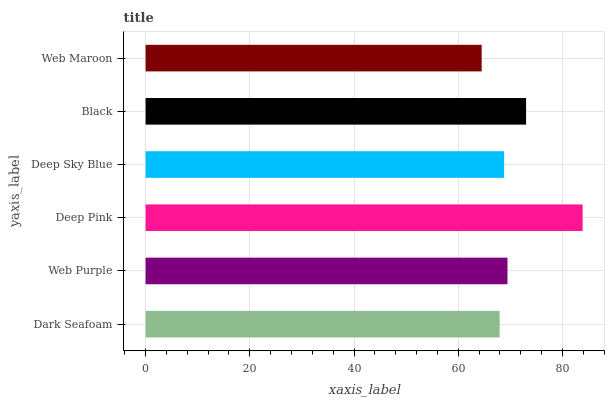Is Web Maroon the minimum?
Answer yes or no. Yes. Is Deep Pink the maximum?
Answer yes or no. Yes. Is Web Purple the minimum?
Answer yes or no. No. Is Web Purple the maximum?
Answer yes or no. No. Is Web Purple greater than Dark Seafoam?
Answer yes or no. Yes. Is Dark Seafoam less than Web Purple?
Answer yes or no. Yes. Is Dark Seafoam greater than Web Purple?
Answer yes or no. No. Is Web Purple less than Dark Seafoam?
Answer yes or no. No. Is Web Purple the high median?
Answer yes or no. Yes. Is Deep Sky Blue the low median?
Answer yes or no. Yes. Is Dark Seafoam the high median?
Answer yes or no. No. Is Web Purple the low median?
Answer yes or no. No. 